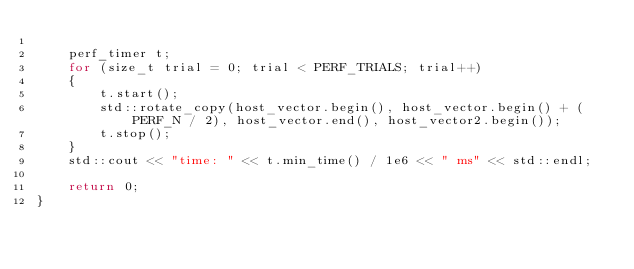Convert code to text. <code><loc_0><loc_0><loc_500><loc_500><_C++_>
    perf_timer t;
    for (size_t trial = 0; trial < PERF_TRIALS; trial++)
    {
        t.start();
        std::rotate_copy(host_vector.begin(), host_vector.begin() + (PERF_N / 2), host_vector.end(), host_vector2.begin());
        t.stop();
    }
    std::cout << "time: " << t.min_time() / 1e6 << " ms" << std::endl;

    return 0;
}
</code> 